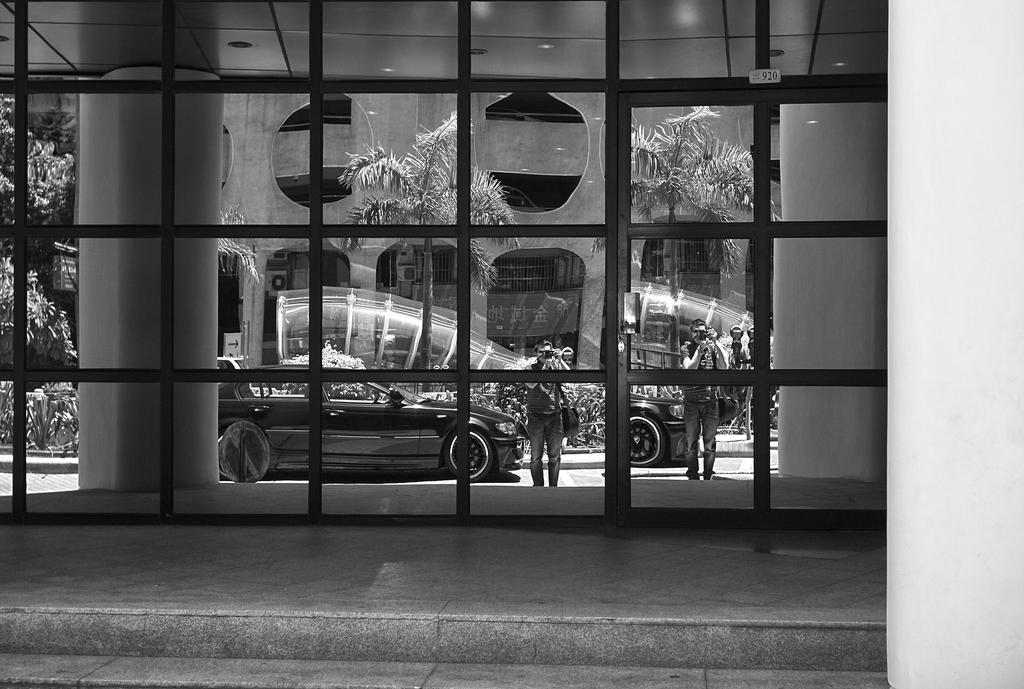What type of door is present in the image? There is a glass door with grilles in the image. What can be seen on the other side of the glass door? Vehicles and persons holding cameras are visible on the other side of the glass door. What type of vegetation is visible in the image? There are trees visible in the image. What type of man-made structures can be seen in the image? There are buildings visible in the image. What type of tray is being used by the trees to hold their leaves in the image? There is no tray present in the image, and trees do not use trays to hold their leaves. 